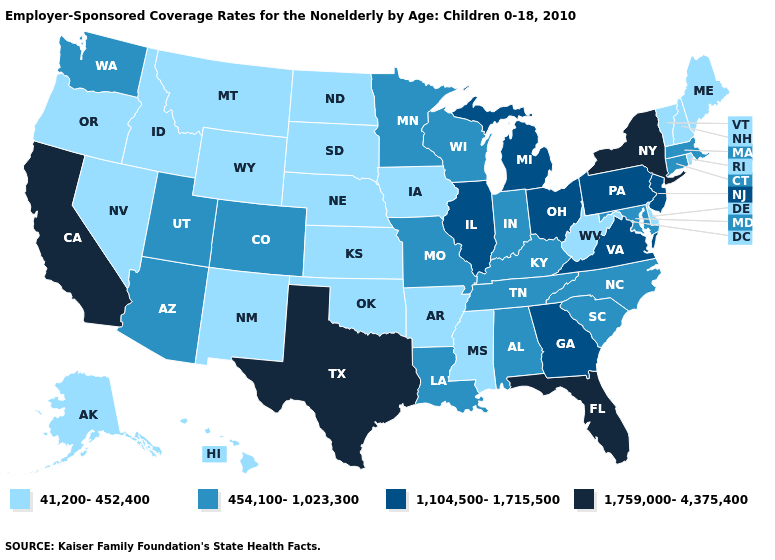Name the states that have a value in the range 41,200-452,400?
Quick response, please. Alaska, Arkansas, Delaware, Hawaii, Idaho, Iowa, Kansas, Maine, Mississippi, Montana, Nebraska, Nevada, New Hampshire, New Mexico, North Dakota, Oklahoma, Oregon, Rhode Island, South Dakota, Vermont, West Virginia, Wyoming. Does Michigan have the lowest value in the MidWest?
Answer briefly. No. What is the value of South Dakota?
Quick response, please. 41,200-452,400. Name the states that have a value in the range 41,200-452,400?
Quick response, please. Alaska, Arkansas, Delaware, Hawaii, Idaho, Iowa, Kansas, Maine, Mississippi, Montana, Nebraska, Nevada, New Hampshire, New Mexico, North Dakota, Oklahoma, Oregon, Rhode Island, South Dakota, Vermont, West Virginia, Wyoming. Name the states that have a value in the range 41,200-452,400?
Give a very brief answer. Alaska, Arkansas, Delaware, Hawaii, Idaho, Iowa, Kansas, Maine, Mississippi, Montana, Nebraska, Nevada, New Hampshire, New Mexico, North Dakota, Oklahoma, Oregon, Rhode Island, South Dakota, Vermont, West Virginia, Wyoming. Which states have the lowest value in the USA?
Give a very brief answer. Alaska, Arkansas, Delaware, Hawaii, Idaho, Iowa, Kansas, Maine, Mississippi, Montana, Nebraska, Nevada, New Hampshire, New Mexico, North Dakota, Oklahoma, Oregon, Rhode Island, South Dakota, Vermont, West Virginia, Wyoming. Is the legend a continuous bar?
Quick response, please. No. Name the states that have a value in the range 1,759,000-4,375,400?
Short answer required. California, Florida, New York, Texas. Name the states that have a value in the range 1,104,500-1,715,500?
Short answer required. Georgia, Illinois, Michigan, New Jersey, Ohio, Pennsylvania, Virginia. Does Maryland have the same value as Pennsylvania?
Answer briefly. No. Does Delaware have a lower value than Tennessee?
Write a very short answer. Yes. What is the highest value in the USA?
Write a very short answer. 1,759,000-4,375,400. What is the value of Massachusetts?
Concise answer only. 454,100-1,023,300. What is the value of New York?
Write a very short answer. 1,759,000-4,375,400. Which states have the lowest value in the USA?
Concise answer only. Alaska, Arkansas, Delaware, Hawaii, Idaho, Iowa, Kansas, Maine, Mississippi, Montana, Nebraska, Nevada, New Hampshire, New Mexico, North Dakota, Oklahoma, Oregon, Rhode Island, South Dakota, Vermont, West Virginia, Wyoming. 